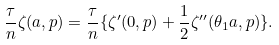Convert formula to latex. <formula><loc_0><loc_0><loc_500><loc_500>\frac { \tau } { n } \zeta ( a , p ) = \frac { \tau } { n } \{ \zeta ^ { \prime } ( 0 , p ) + \frac { 1 } { 2 } \zeta ^ { \prime \prime } ( \theta _ { 1 } a , p ) \} .</formula> 